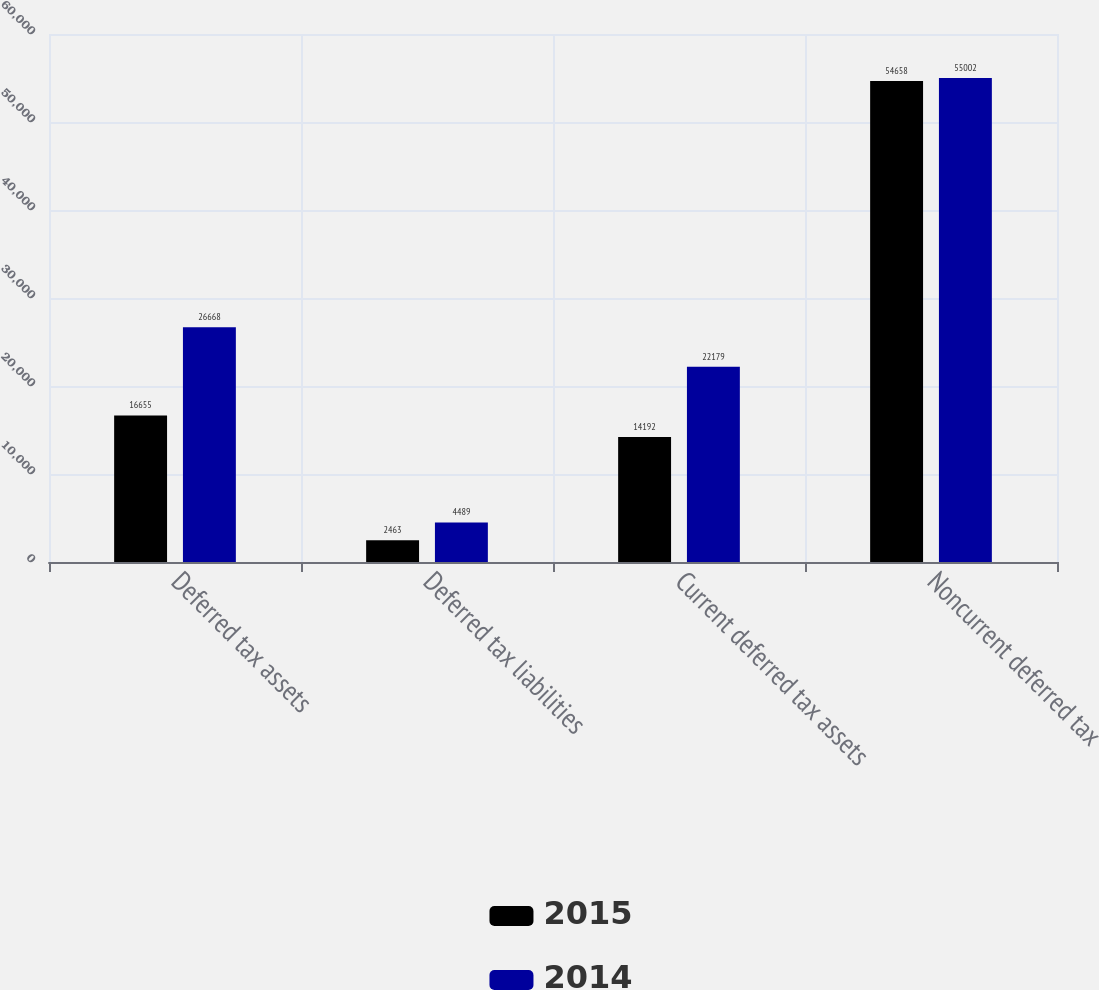<chart> <loc_0><loc_0><loc_500><loc_500><stacked_bar_chart><ecel><fcel>Deferred tax assets<fcel>Deferred tax liabilities<fcel>Current deferred tax assets<fcel>Noncurrent deferred tax<nl><fcel>2015<fcel>16655<fcel>2463<fcel>14192<fcel>54658<nl><fcel>2014<fcel>26668<fcel>4489<fcel>22179<fcel>55002<nl></chart> 